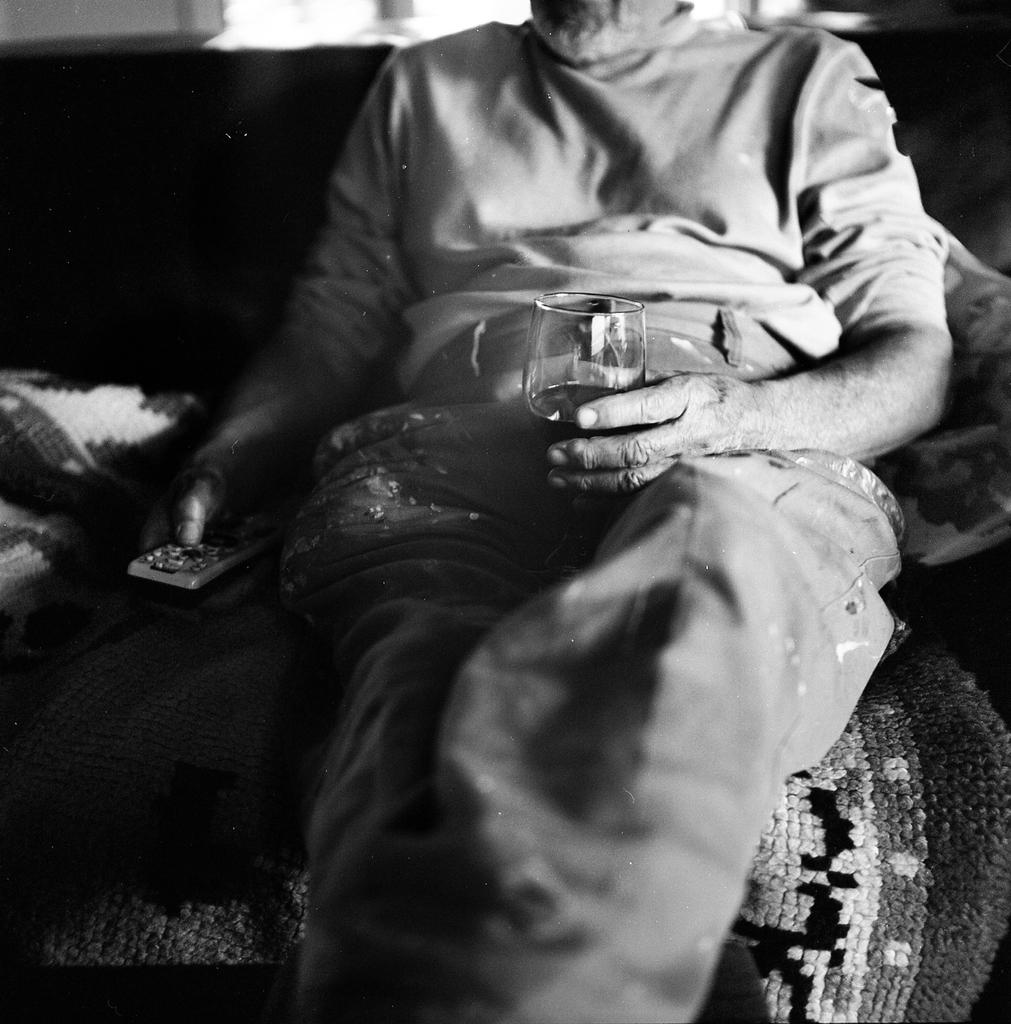What is the person in the image doing? The person is sitting on a couch. What is the person holding in one hand? The person is holding a remote in one hand. What is the person holding in the other hand? The person is holding a glass with juice in the other hand. What type of gold object is the person offering to someone in the image? There is no gold object present in the image, and the person is not offering anything to anyone. 